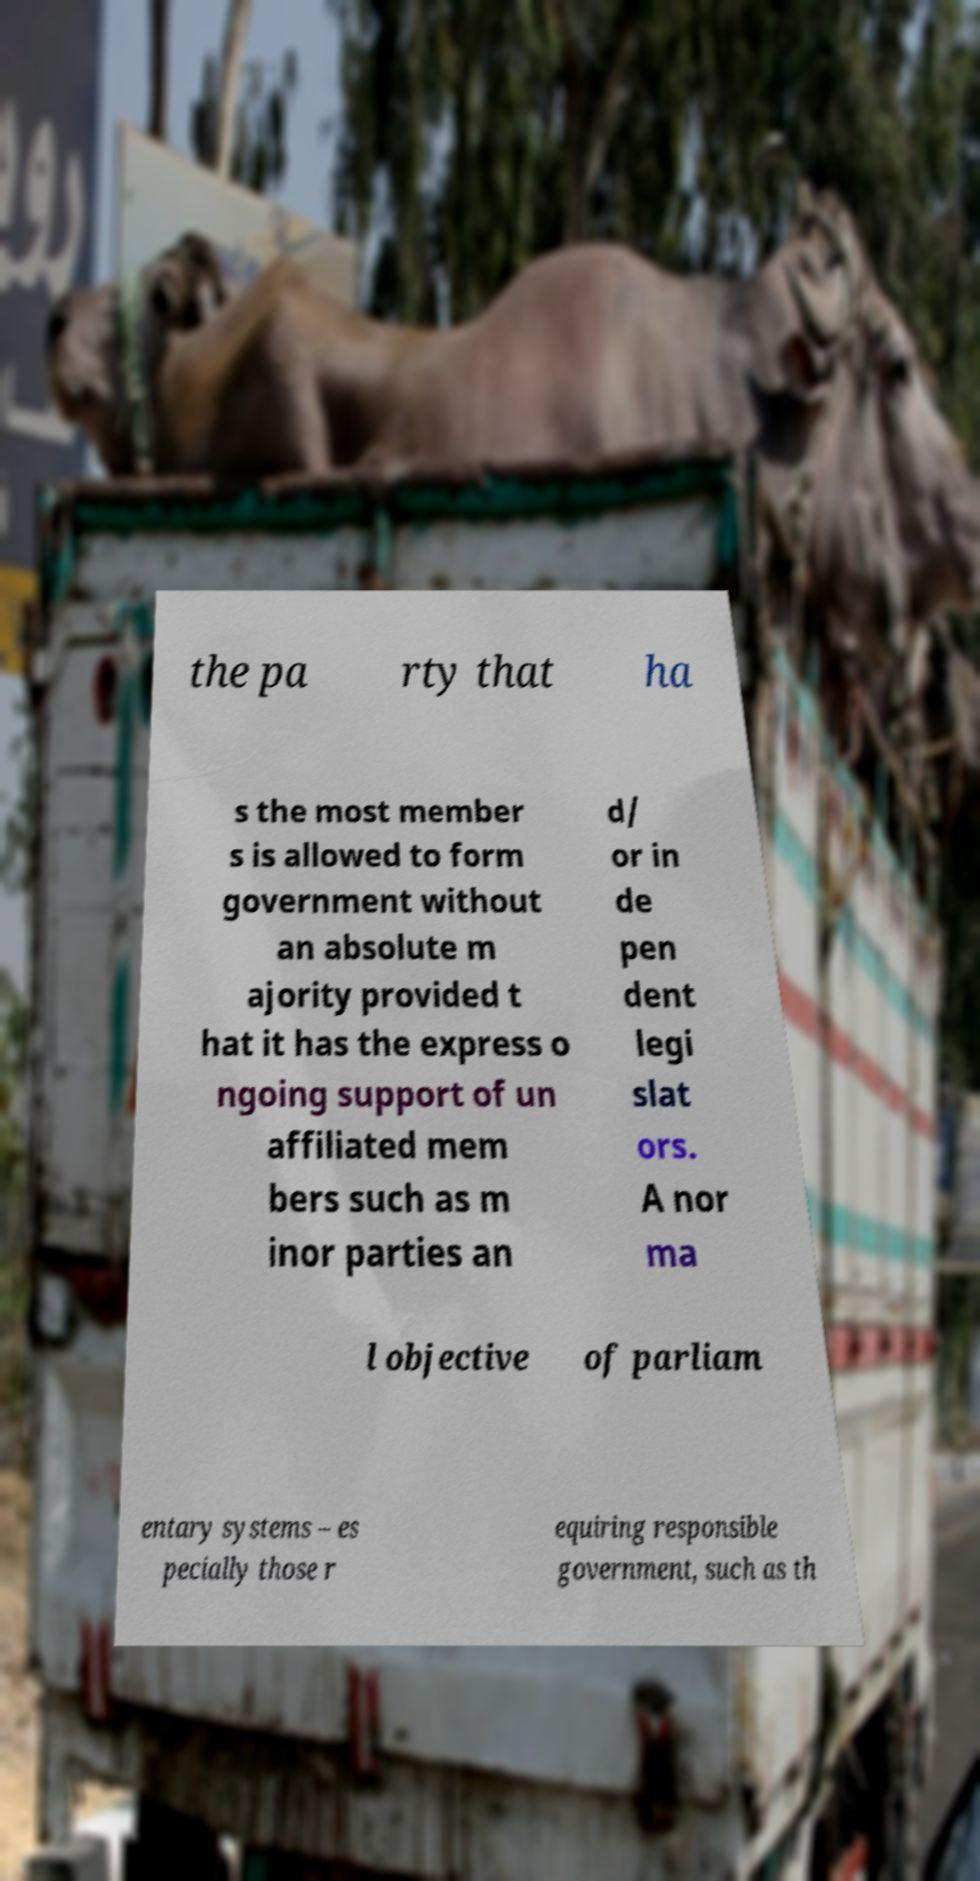Can you accurately transcribe the text from the provided image for me? the pa rty that ha s the most member s is allowed to form government without an absolute m ajority provided t hat it has the express o ngoing support of un affiliated mem bers such as m inor parties an d/ or in de pen dent legi slat ors. A nor ma l objective of parliam entary systems – es pecially those r equiring responsible government, such as th 